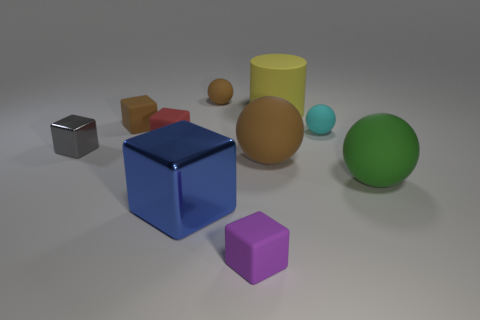Are there any brown balls that have the same size as the blue object?
Ensure brevity in your answer.  Yes. What number of rubber objects are either tiny blue cubes or tiny purple things?
Provide a succinct answer. 1. What number of purple matte cubes are there?
Make the answer very short. 1. Are the large object behind the small gray cube and the small brown thing to the right of the blue object made of the same material?
Offer a terse response. Yes. The yellow cylinder that is made of the same material as the small brown sphere is what size?
Keep it short and to the point. Large. The small thing that is to the left of the tiny brown cube has what shape?
Offer a very short reply. Cube. There is a ball behind the big yellow cylinder; is its color the same as the big matte sphere left of the yellow cylinder?
Make the answer very short. Yes. Are there any small red cubes?
Your answer should be compact. Yes. There is a brown thing that is on the right side of the ball left of the block in front of the blue thing; what is its shape?
Offer a terse response. Sphere. How many red blocks are in front of the red object?
Give a very brief answer. 0. 